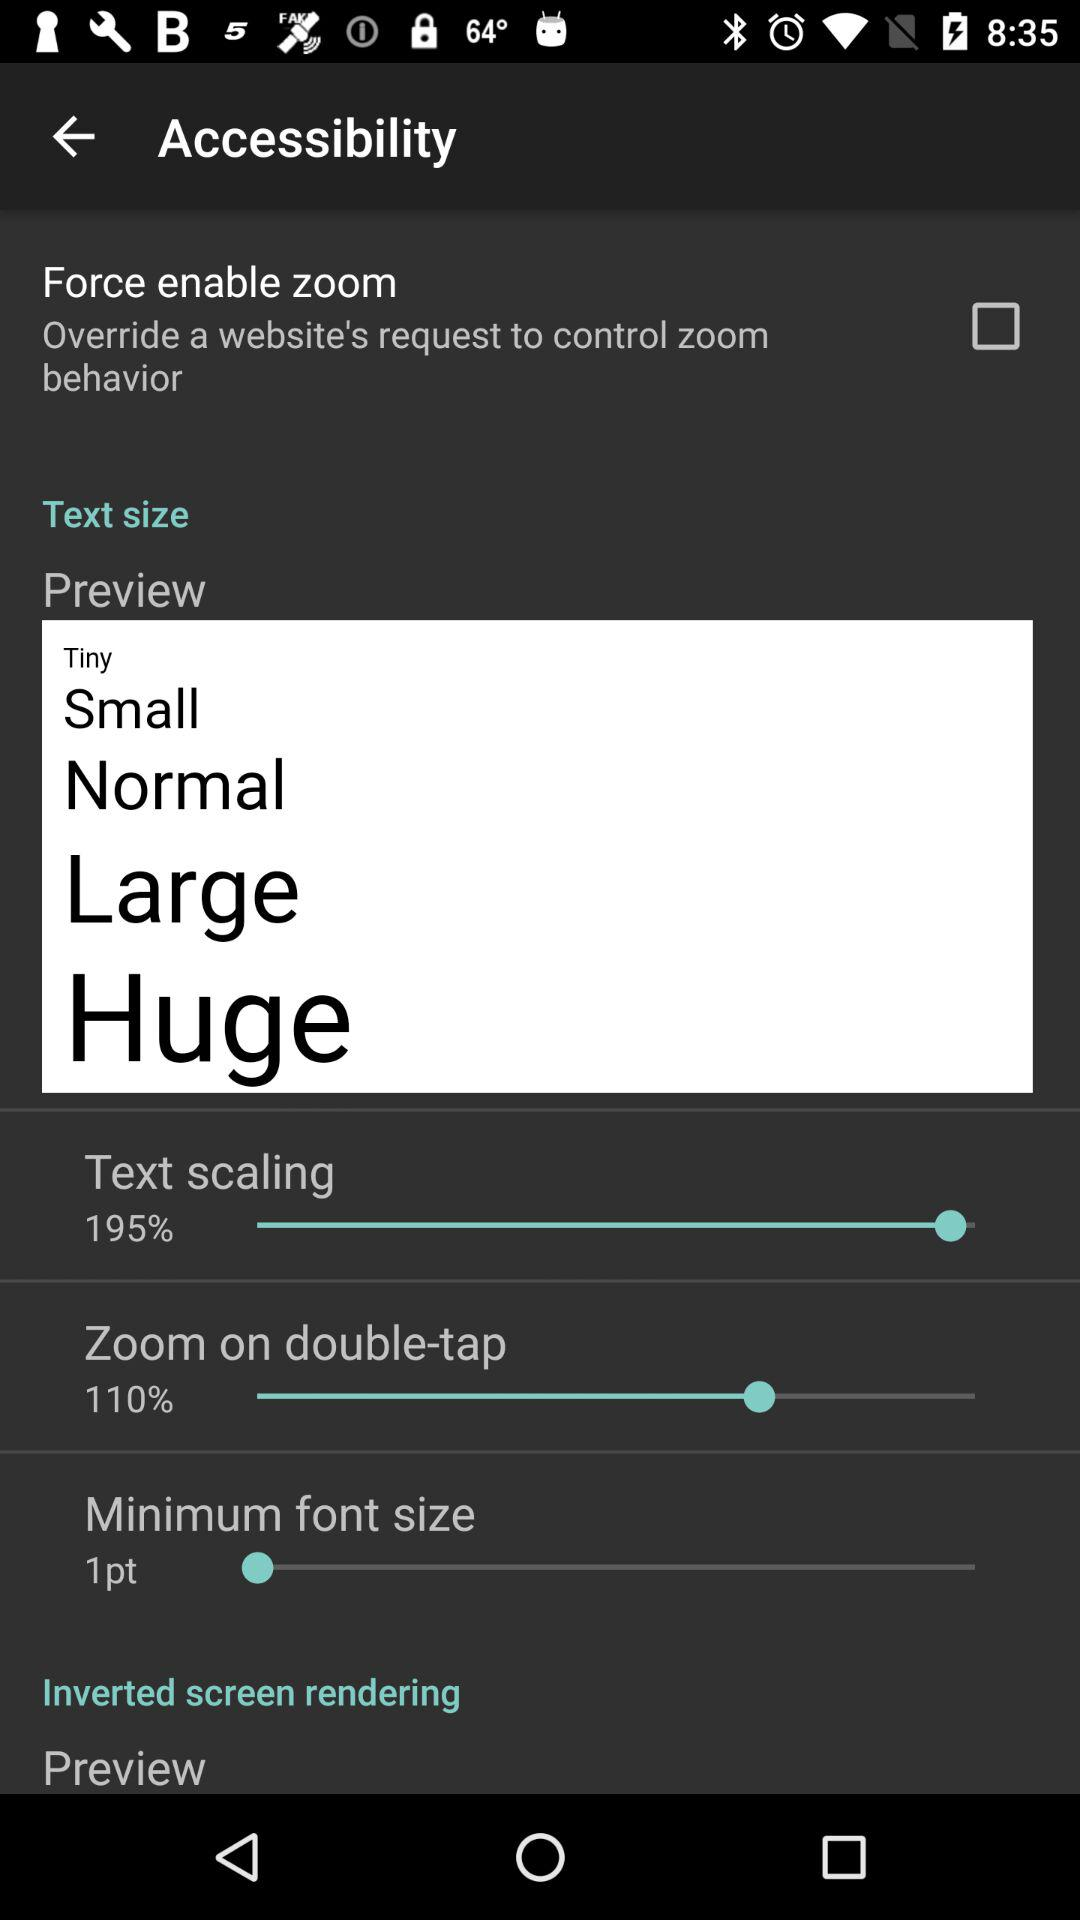What is the percentage of "Zoom on double-tap"? The percentage is 110. 